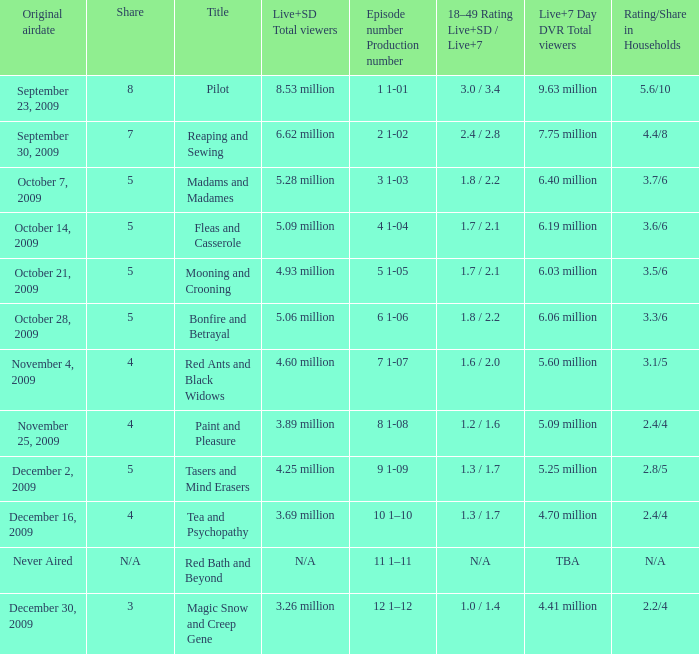What are the "18–49 Rating Live+SD" ratings and "Live+7" ratings, respectively, for the episode that originally aired on October 14, 2009? 1.7 / 2.1. 